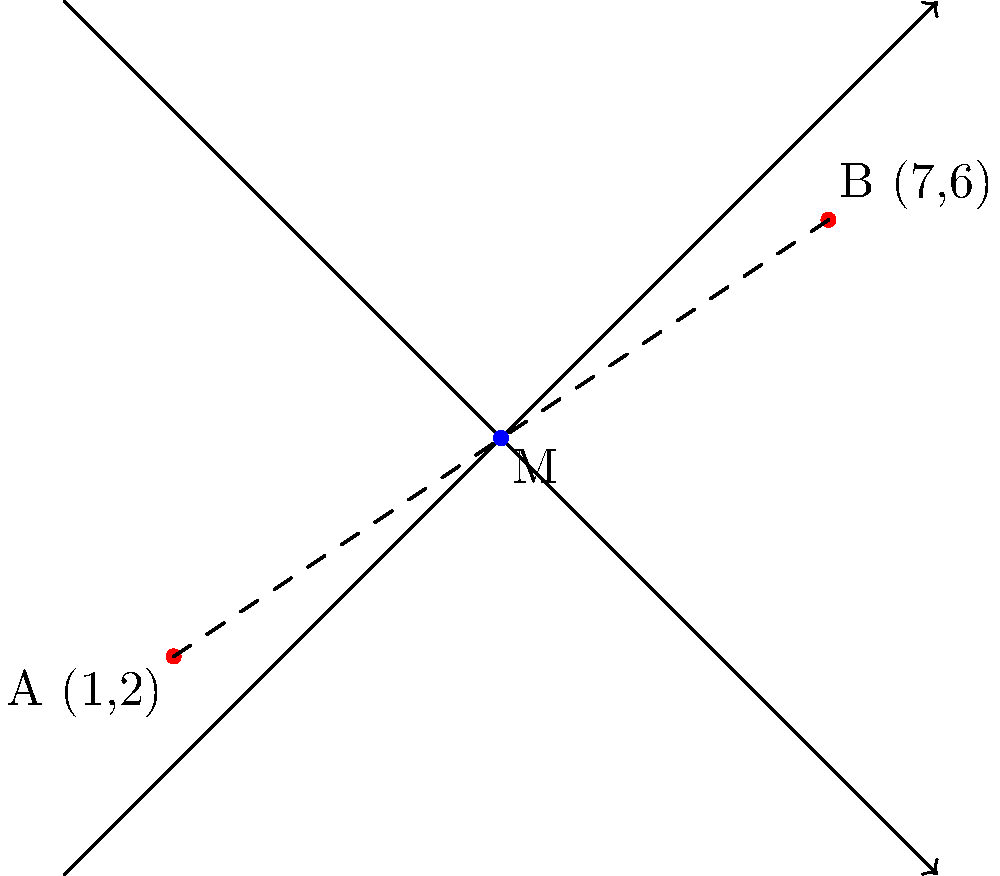On a city map, two iconic hip-hop landmarks are located at coordinates A(1,2) and B(7,6). As part of a street art project celebrating the genre's history, you need to determine the midpoint M between these two locations for a centerpiece installation. Calculate the coordinates of point M. To find the midpoint M between two points A(x₁,y₁) and B(x₂,y₂), we use the midpoint formula:

$$ M = (\frac{x_1 + x_2}{2}, \frac{y_1 + y_2}{2}) $$

Given:
A(1,2) and B(7,6)

Step 1: Calculate the x-coordinate of the midpoint
$$ x_M = \frac{x_1 + x_2}{2} = \frac{1 + 7}{2} = \frac{8}{2} = 4 $$

Step 2: Calculate the y-coordinate of the midpoint
$$ y_M = \frac{y_1 + y_2}{2} = \frac{2 + 6}{2} = \frac{8}{2} = 4 $$

Step 3: Combine the results
The midpoint M has coordinates (4,4)
Answer: M(4,4) 